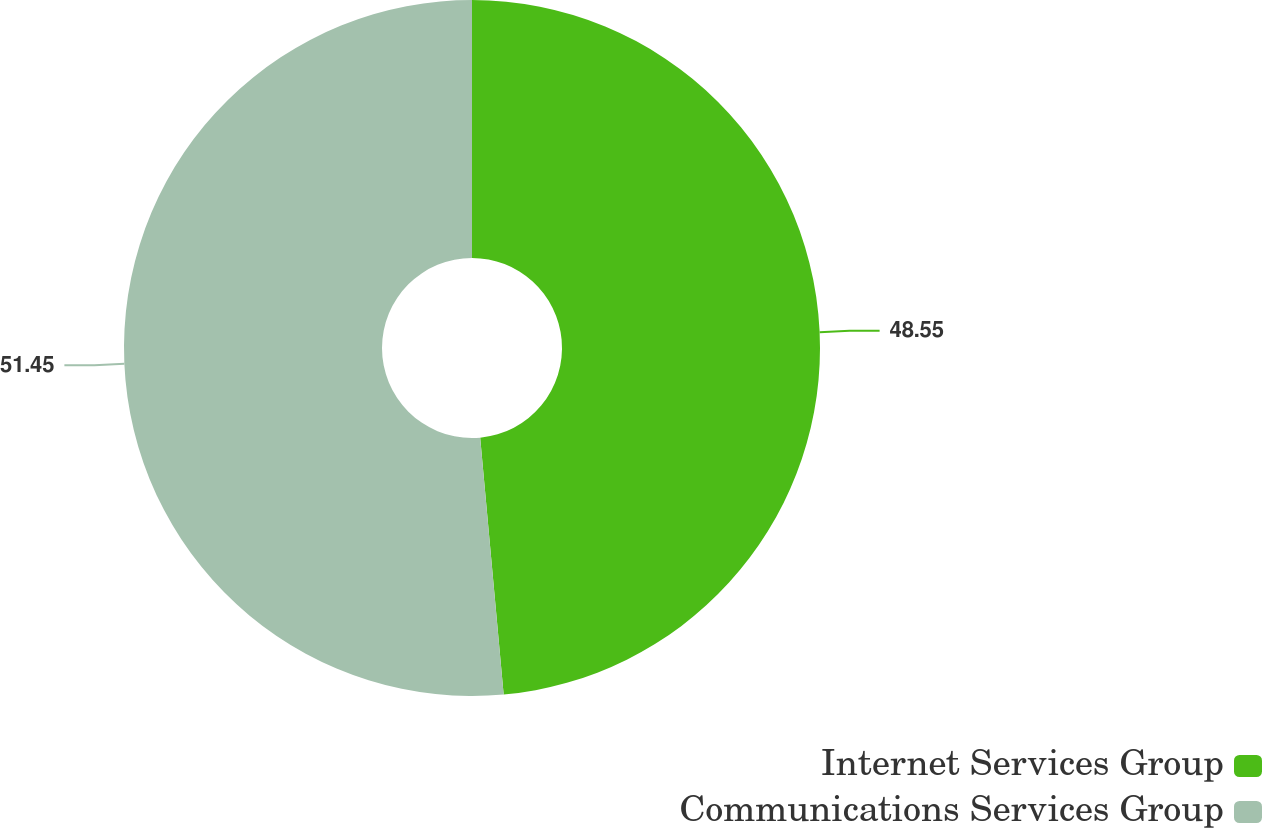Convert chart to OTSL. <chart><loc_0><loc_0><loc_500><loc_500><pie_chart><fcel>Internet Services Group<fcel>Communications Services Group<nl><fcel>48.55%<fcel>51.45%<nl></chart> 